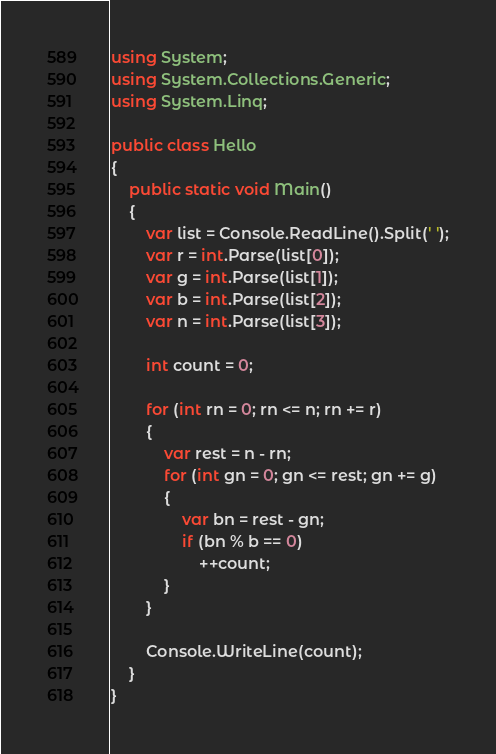<code> <loc_0><loc_0><loc_500><loc_500><_C#_>using System;
using System.Collections.Generic;
using System.Linq;

public class Hello
{
    public static void Main()
    {
        var list = Console.ReadLine().Split(' ');
        var r = int.Parse(list[0]);
        var g = int.Parse(list[1]);
        var b = int.Parse(list[2]);
        var n = int.Parse(list[3]);

        int count = 0;

        for (int rn = 0; rn <= n; rn += r)
        {
            var rest = n - rn;
            for (int gn = 0; gn <= rest; gn += g)
            {
                var bn = rest - gn;
                if (bn % b == 0)
                    ++count;
            }
        }

        Console.WriteLine(count);
    }
}
</code> 